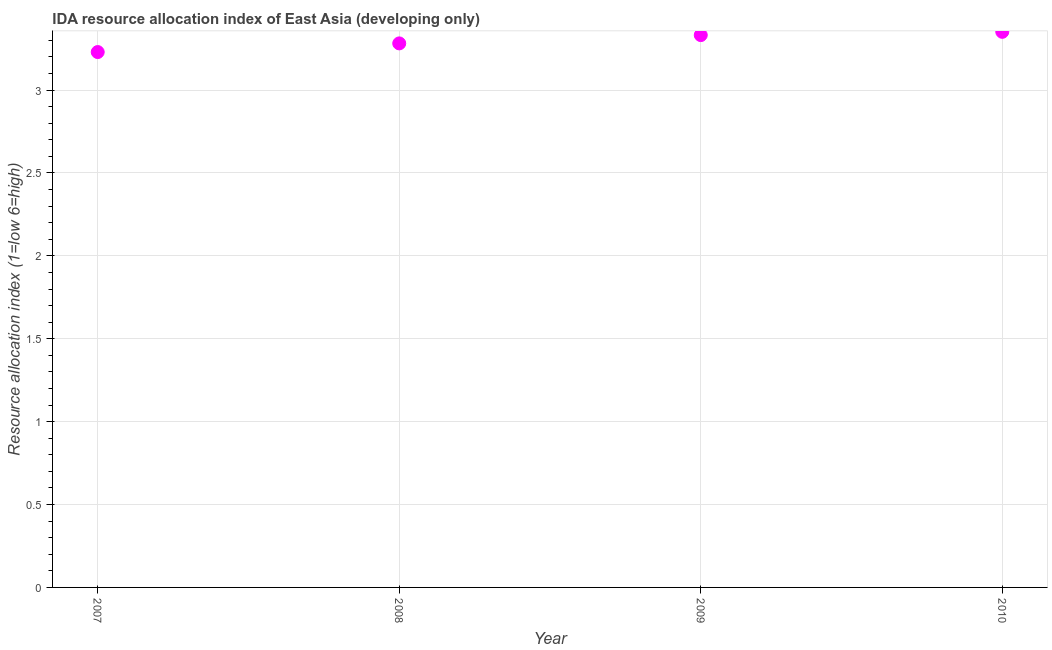What is the ida resource allocation index in 2010?
Offer a terse response. 3.35. Across all years, what is the maximum ida resource allocation index?
Your response must be concise. 3.35. Across all years, what is the minimum ida resource allocation index?
Provide a short and direct response. 3.23. What is the sum of the ida resource allocation index?
Your answer should be very brief. 13.19. What is the difference between the ida resource allocation index in 2009 and 2010?
Give a very brief answer. -0.02. What is the average ida resource allocation index per year?
Give a very brief answer. 3.3. What is the median ida resource allocation index?
Provide a succinct answer. 3.31. What is the ratio of the ida resource allocation index in 2009 to that in 2010?
Your response must be concise. 0.99. Is the ida resource allocation index in 2007 less than that in 2009?
Offer a very short reply. Yes. What is the difference between the highest and the second highest ida resource allocation index?
Provide a short and direct response. 0.02. What is the difference between the highest and the lowest ida resource allocation index?
Your response must be concise. 0.12. How many dotlines are there?
Your answer should be compact. 1. Are the values on the major ticks of Y-axis written in scientific E-notation?
Your answer should be very brief. No. Does the graph contain grids?
Keep it short and to the point. Yes. What is the title of the graph?
Offer a very short reply. IDA resource allocation index of East Asia (developing only). What is the label or title of the Y-axis?
Provide a succinct answer. Resource allocation index (1=low 6=high). What is the Resource allocation index (1=low 6=high) in 2007?
Provide a succinct answer. 3.23. What is the Resource allocation index (1=low 6=high) in 2008?
Provide a short and direct response. 3.28. What is the Resource allocation index (1=low 6=high) in 2009?
Give a very brief answer. 3.33. What is the Resource allocation index (1=low 6=high) in 2010?
Make the answer very short. 3.35. What is the difference between the Resource allocation index (1=low 6=high) in 2007 and 2008?
Provide a succinct answer. -0.05. What is the difference between the Resource allocation index (1=low 6=high) in 2007 and 2009?
Offer a terse response. -0.1. What is the difference between the Resource allocation index (1=low 6=high) in 2007 and 2010?
Your answer should be compact. -0.12. What is the difference between the Resource allocation index (1=low 6=high) in 2008 and 2009?
Your answer should be compact. -0.05. What is the difference between the Resource allocation index (1=low 6=high) in 2008 and 2010?
Your answer should be very brief. -0.07. What is the difference between the Resource allocation index (1=low 6=high) in 2009 and 2010?
Your answer should be very brief. -0.02. What is the ratio of the Resource allocation index (1=low 6=high) in 2007 to that in 2008?
Provide a short and direct response. 0.98. What is the ratio of the Resource allocation index (1=low 6=high) in 2007 to that in 2010?
Your response must be concise. 0.96. What is the ratio of the Resource allocation index (1=low 6=high) in 2008 to that in 2009?
Ensure brevity in your answer.  0.98. What is the ratio of the Resource allocation index (1=low 6=high) in 2008 to that in 2010?
Offer a terse response. 0.98. What is the ratio of the Resource allocation index (1=low 6=high) in 2009 to that in 2010?
Provide a short and direct response. 0.99. 